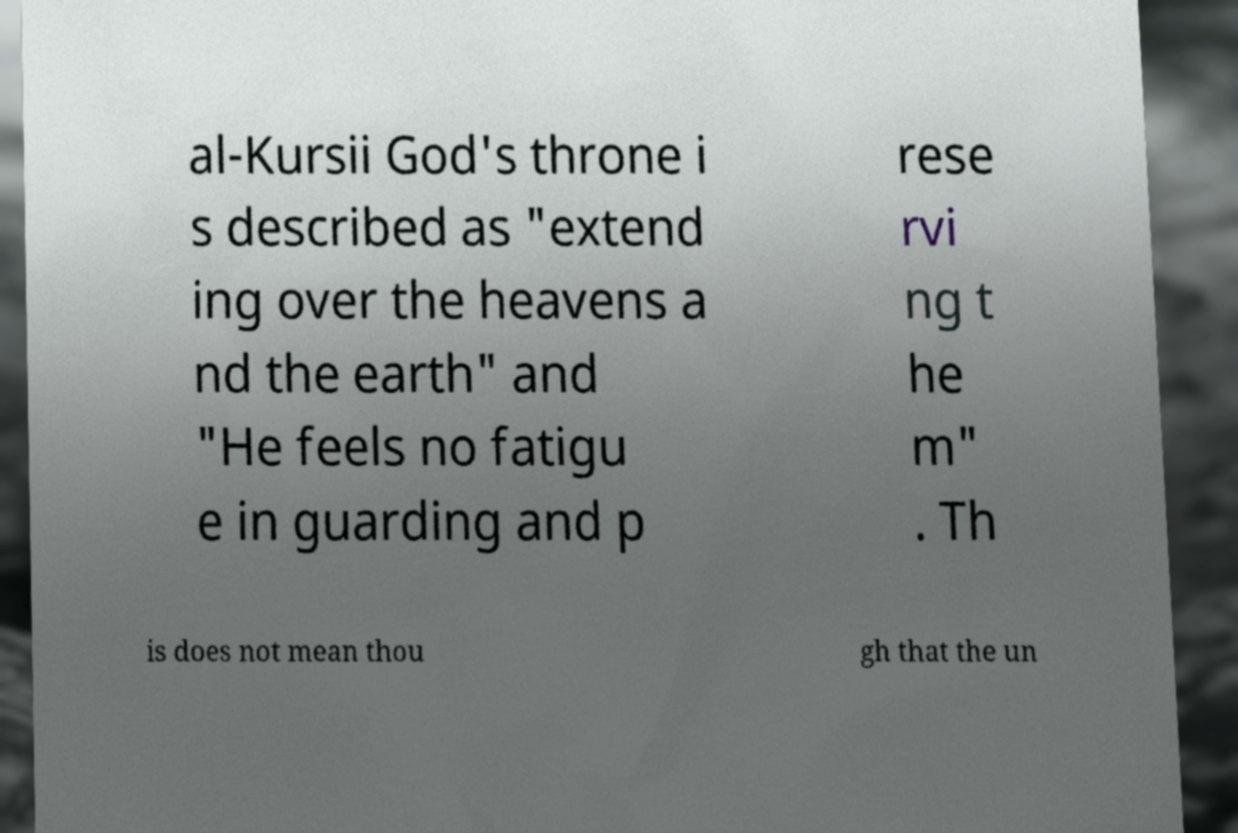Please read and relay the text visible in this image. What does it say? al-Kursii God's throne i s described as "extend ing over the heavens a nd the earth" and "He feels no fatigu e in guarding and p rese rvi ng t he m" . Th is does not mean thou gh that the un 